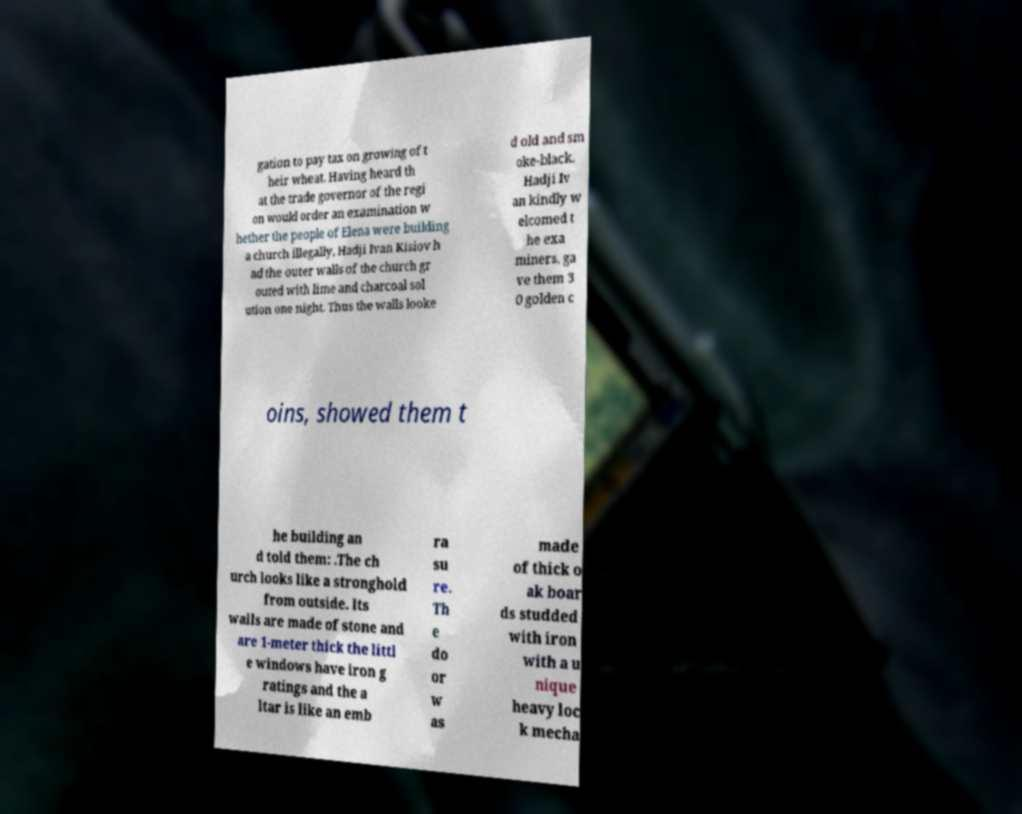Could you assist in decoding the text presented in this image and type it out clearly? gation to pay tax on growing of t heir wheat. Having heard th at the trade governor of the regi on would order an examination w hether the people of Elena were building a church illegally, Hadji Ivan Kisiov h ad the outer walls of the church gr outed with lime and charcoal sol ution one night. Thus the walls looke d old and sm oke-black. Hadji Iv an kindly w elcomed t he exa miners, ga ve them 3 0 golden c oins, showed them t he building an d told them: .The ch urch looks like a stronghold from outside. Its walls are made of stone and are 1-meter thick the littl e windows have iron g ratings and the a ltar is like an emb ra su re. Th e do or w as made of thick o ak boar ds studded with iron with a u nique heavy loc k mecha 